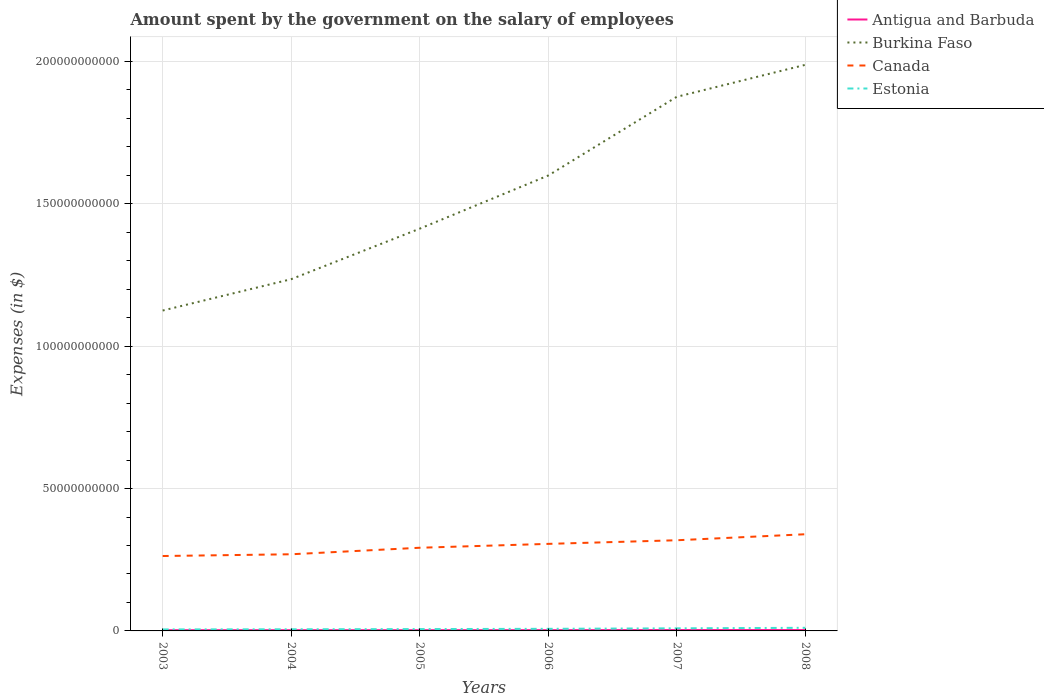Across all years, what is the maximum amount spent on the salary of employees by the government in Estonia?
Your response must be concise. 5.26e+08. What is the total amount spent on the salary of employees by the government in Antigua and Barbuda in the graph?
Give a very brief answer. -1.80e+07. What is the difference between the highest and the second highest amount spent on the salary of employees by the government in Canada?
Keep it short and to the point. 7.64e+09. What is the difference between the highest and the lowest amount spent on the salary of employees by the government in Burkina Faso?
Provide a short and direct response. 3. Is the amount spent on the salary of employees by the government in Estonia strictly greater than the amount spent on the salary of employees by the government in Antigua and Barbuda over the years?
Your response must be concise. No. What is the difference between two consecutive major ticks on the Y-axis?
Offer a very short reply. 5.00e+1. Does the graph contain any zero values?
Make the answer very short. No. Does the graph contain grids?
Ensure brevity in your answer.  Yes. How are the legend labels stacked?
Offer a terse response. Vertical. What is the title of the graph?
Ensure brevity in your answer.  Amount spent by the government on the salary of employees. What is the label or title of the Y-axis?
Give a very brief answer. Expenses (in $). What is the Expenses (in $) of Antigua and Barbuda in 2003?
Your answer should be compact. 2.50e+08. What is the Expenses (in $) in Burkina Faso in 2003?
Give a very brief answer. 1.13e+11. What is the Expenses (in $) in Canada in 2003?
Provide a short and direct response. 2.63e+1. What is the Expenses (in $) in Estonia in 2003?
Your response must be concise. 5.26e+08. What is the Expenses (in $) in Antigua and Barbuda in 2004?
Your answer should be very brief. 2.51e+08. What is the Expenses (in $) of Burkina Faso in 2004?
Keep it short and to the point. 1.24e+11. What is the Expenses (in $) of Canada in 2004?
Your response must be concise. 2.69e+1. What is the Expenses (in $) of Estonia in 2004?
Provide a short and direct response. 5.75e+08. What is the Expenses (in $) of Antigua and Barbuda in 2005?
Make the answer very short. 2.53e+08. What is the Expenses (in $) in Burkina Faso in 2005?
Your answer should be very brief. 1.41e+11. What is the Expenses (in $) of Canada in 2005?
Offer a very short reply. 2.92e+1. What is the Expenses (in $) of Estonia in 2005?
Give a very brief answer. 6.46e+08. What is the Expenses (in $) of Antigua and Barbuda in 2006?
Provide a short and direct response. 2.68e+08. What is the Expenses (in $) of Burkina Faso in 2006?
Provide a succinct answer. 1.60e+11. What is the Expenses (in $) of Canada in 2006?
Make the answer very short. 3.06e+1. What is the Expenses (in $) of Estonia in 2006?
Provide a short and direct response. 7.36e+08. What is the Expenses (in $) of Antigua and Barbuda in 2007?
Provide a short and direct response. 3.09e+08. What is the Expenses (in $) of Burkina Faso in 2007?
Provide a succinct answer. 1.88e+11. What is the Expenses (in $) of Canada in 2007?
Ensure brevity in your answer.  3.18e+1. What is the Expenses (in $) in Estonia in 2007?
Provide a succinct answer. 9.16e+08. What is the Expenses (in $) of Antigua and Barbuda in 2008?
Your response must be concise. 3.00e+08. What is the Expenses (in $) of Burkina Faso in 2008?
Make the answer very short. 1.99e+11. What is the Expenses (in $) in Canada in 2008?
Provide a short and direct response. 3.40e+1. What is the Expenses (in $) of Estonia in 2008?
Your response must be concise. 1.09e+09. Across all years, what is the maximum Expenses (in $) in Antigua and Barbuda?
Your response must be concise. 3.09e+08. Across all years, what is the maximum Expenses (in $) of Burkina Faso?
Offer a terse response. 1.99e+11. Across all years, what is the maximum Expenses (in $) in Canada?
Offer a very short reply. 3.40e+1. Across all years, what is the maximum Expenses (in $) in Estonia?
Your answer should be compact. 1.09e+09. Across all years, what is the minimum Expenses (in $) in Antigua and Barbuda?
Provide a short and direct response. 2.50e+08. Across all years, what is the minimum Expenses (in $) in Burkina Faso?
Provide a short and direct response. 1.13e+11. Across all years, what is the minimum Expenses (in $) of Canada?
Your answer should be compact. 2.63e+1. Across all years, what is the minimum Expenses (in $) in Estonia?
Offer a very short reply. 5.26e+08. What is the total Expenses (in $) of Antigua and Barbuda in the graph?
Ensure brevity in your answer.  1.63e+09. What is the total Expenses (in $) of Burkina Faso in the graph?
Provide a short and direct response. 9.24e+11. What is the total Expenses (in $) in Canada in the graph?
Your response must be concise. 1.79e+11. What is the total Expenses (in $) in Estonia in the graph?
Provide a succinct answer. 4.49e+09. What is the difference between the Expenses (in $) in Antigua and Barbuda in 2003 and that in 2004?
Offer a very short reply. -9.00e+05. What is the difference between the Expenses (in $) in Burkina Faso in 2003 and that in 2004?
Ensure brevity in your answer.  -1.10e+1. What is the difference between the Expenses (in $) in Canada in 2003 and that in 2004?
Your response must be concise. -6.14e+08. What is the difference between the Expenses (in $) in Estonia in 2003 and that in 2004?
Give a very brief answer. -4.92e+07. What is the difference between the Expenses (in $) of Antigua and Barbuda in 2003 and that in 2005?
Your response must be concise. -2.60e+06. What is the difference between the Expenses (in $) of Burkina Faso in 2003 and that in 2005?
Provide a short and direct response. -2.88e+1. What is the difference between the Expenses (in $) of Canada in 2003 and that in 2005?
Your answer should be compact. -2.90e+09. What is the difference between the Expenses (in $) in Estonia in 2003 and that in 2005?
Provide a short and direct response. -1.20e+08. What is the difference between the Expenses (in $) in Antigua and Barbuda in 2003 and that in 2006?
Your answer should be compact. -1.80e+07. What is the difference between the Expenses (in $) in Burkina Faso in 2003 and that in 2006?
Keep it short and to the point. -4.74e+1. What is the difference between the Expenses (in $) in Canada in 2003 and that in 2006?
Ensure brevity in your answer.  -4.26e+09. What is the difference between the Expenses (in $) of Estonia in 2003 and that in 2006?
Keep it short and to the point. -2.10e+08. What is the difference between the Expenses (in $) of Antigua and Barbuda in 2003 and that in 2007?
Your answer should be compact. -5.88e+07. What is the difference between the Expenses (in $) of Burkina Faso in 2003 and that in 2007?
Your answer should be very brief. -7.51e+1. What is the difference between the Expenses (in $) in Canada in 2003 and that in 2007?
Your response must be concise. -5.54e+09. What is the difference between the Expenses (in $) of Estonia in 2003 and that in 2007?
Give a very brief answer. -3.90e+08. What is the difference between the Expenses (in $) of Antigua and Barbuda in 2003 and that in 2008?
Offer a very short reply. -5.02e+07. What is the difference between the Expenses (in $) in Burkina Faso in 2003 and that in 2008?
Give a very brief answer. -8.63e+1. What is the difference between the Expenses (in $) in Canada in 2003 and that in 2008?
Your answer should be compact. -7.64e+09. What is the difference between the Expenses (in $) in Estonia in 2003 and that in 2008?
Provide a succinct answer. -5.68e+08. What is the difference between the Expenses (in $) in Antigua and Barbuda in 2004 and that in 2005?
Keep it short and to the point. -1.70e+06. What is the difference between the Expenses (in $) in Burkina Faso in 2004 and that in 2005?
Keep it short and to the point. -1.77e+1. What is the difference between the Expenses (in $) of Canada in 2004 and that in 2005?
Provide a short and direct response. -2.29e+09. What is the difference between the Expenses (in $) in Estonia in 2004 and that in 2005?
Your answer should be very brief. -7.10e+07. What is the difference between the Expenses (in $) in Antigua and Barbuda in 2004 and that in 2006?
Offer a very short reply. -1.71e+07. What is the difference between the Expenses (in $) in Burkina Faso in 2004 and that in 2006?
Give a very brief answer. -3.64e+1. What is the difference between the Expenses (in $) in Canada in 2004 and that in 2006?
Offer a terse response. -3.65e+09. What is the difference between the Expenses (in $) in Estonia in 2004 and that in 2006?
Provide a succinct answer. -1.60e+08. What is the difference between the Expenses (in $) of Antigua and Barbuda in 2004 and that in 2007?
Make the answer very short. -5.79e+07. What is the difference between the Expenses (in $) in Burkina Faso in 2004 and that in 2007?
Your answer should be compact. -6.41e+1. What is the difference between the Expenses (in $) in Canada in 2004 and that in 2007?
Offer a terse response. -4.92e+09. What is the difference between the Expenses (in $) of Estonia in 2004 and that in 2007?
Provide a short and direct response. -3.41e+08. What is the difference between the Expenses (in $) in Antigua and Barbuda in 2004 and that in 2008?
Make the answer very short. -4.93e+07. What is the difference between the Expenses (in $) of Burkina Faso in 2004 and that in 2008?
Your answer should be compact. -7.53e+1. What is the difference between the Expenses (in $) in Canada in 2004 and that in 2008?
Your answer should be very brief. -7.03e+09. What is the difference between the Expenses (in $) of Estonia in 2004 and that in 2008?
Give a very brief answer. -5.19e+08. What is the difference between the Expenses (in $) in Antigua and Barbuda in 2005 and that in 2006?
Your answer should be very brief. -1.54e+07. What is the difference between the Expenses (in $) of Burkina Faso in 2005 and that in 2006?
Offer a terse response. -1.87e+1. What is the difference between the Expenses (in $) of Canada in 2005 and that in 2006?
Your answer should be very brief. -1.36e+09. What is the difference between the Expenses (in $) of Estonia in 2005 and that in 2006?
Ensure brevity in your answer.  -8.94e+07. What is the difference between the Expenses (in $) of Antigua and Barbuda in 2005 and that in 2007?
Offer a terse response. -5.62e+07. What is the difference between the Expenses (in $) of Burkina Faso in 2005 and that in 2007?
Your response must be concise. -4.63e+1. What is the difference between the Expenses (in $) in Canada in 2005 and that in 2007?
Ensure brevity in your answer.  -2.63e+09. What is the difference between the Expenses (in $) of Estonia in 2005 and that in 2007?
Make the answer very short. -2.70e+08. What is the difference between the Expenses (in $) in Antigua and Barbuda in 2005 and that in 2008?
Your answer should be very brief. -4.76e+07. What is the difference between the Expenses (in $) in Burkina Faso in 2005 and that in 2008?
Your response must be concise. -5.75e+1. What is the difference between the Expenses (in $) in Canada in 2005 and that in 2008?
Provide a succinct answer. -4.74e+09. What is the difference between the Expenses (in $) of Estonia in 2005 and that in 2008?
Your answer should be very brief. -4.48e+08. What is the difference between the Expenses (in $) in Antigua and Barbuda in 2006 and that in 2007?
Offer a terse response. -4.08e+07. What is the difference between the Expenses (in $) of Burkina Faso in 2006 and that in 2007?
Your response must be concise. -2.76e+1. What is the difference between the Expenses (in $) in Canada in 2006 and that in 2007?
Offer a very short reply. -1.27e+09. What is the difference between the Expenses (in $) of Estonia in 2006 and that in 2007?
Make the answer very short. -1.81e+08. What is the difference between the Expenses (in $) in Antigua and Barbuda in 2006 and that in 2008?
Make the answer very short. -3.22e+07. What is the difference between the Expenses (in $) in Burkina Faso in 2006 and that in 2008?
Ensure brevity in your answer.  -3.89e+1. What is the difference between the Expenses (in $) in Canada in 2006 and that in 2008?
Keep it short and to the point. -3.38e+09. What is the difference between the Expenses (in $) of Estonia in 2006 and that in 2008?
Ensure brevity in your answer.  -3.58e+08. What is the difference between the Expenses (in $) of Antigua and Barbuda in 2007 and that in 2008?
Provide a succinct answer. 8.60e+06. What is the difference between the Expenses (in $) of Burkina Faso in 2007 and that in 2008?
Your response must be concise. -1.12e+1. What is the difference between the Expenses (in $) of Canada in 2007 and that in 2008?
Provide a short and direct response. -2.11e+09. What is the difference between the Expenses (in $) in Estonia in 2007 and that in 2008?
Provide a succinct answer. -1.78e+08. What is the difference between the Expenses (in $) of Antigua and Barbuda in 2003 and the Expenses (in $) of Burkina Faso in 2004?
Ensure brevity in your answer.  -1.23e+11. What is the difference between the Expenses (in $) in Antigua and Barbuda in 2003 and the Expenses (in $) in Canada in 2004?
Provide a short and direct response. -2.67e+1. What is the difference between the Expenses (in $) of Antigua and Barbuda in 2003 and the Expenses (in $) of Estonia in 2004?
Provide a short and direct response. -3.25e+08. What is the difference between the Expenses (in $) of Burkina Faso in 2003 and the Expenses (in $) of Canada in 2004?
Keep it short and to the point. 8.56e+1. What is the difference between the Expenses (in $) of Burkina Faso in 2003 and the Expenses (in $) of Estonia in 2004?
Ensure brevity in your answer.  1.12e+11. What is the difference between the Expenses (in $) of Canada in 2003 and the Expenses (in $) of Estonia in 2004?
Give a very brief answer. 2.57e+1. What is the difference between the Expenses (in $) of Antigua and Barbuda in 2003 and the Expenses (in $) of Burkina Faso in 2005?
Your answer should be compact. -1.41e+11. What is the difference between the Expenses (in $) of Antigua and Barbuda in 2003 and the Expenses (in $) of Canada in 2005?
Give a very brief answer. -2.90e+1. What is the difference between the Expenses (in $) in Antigua and Barbuda in 2003 and the Expenses (in $) in Estonia in 2005?
Provide a short and direct response. -3.96e+08. What is the difference between the Expenses (in $) in Burkina Faso in 2003 and the Expenses (in $) in Canada in 2005?
Make the answer very short. 8.33e+1. What is the difference between the Expenses (in $) in Burkina Faso in 2003 and the Expenses (in $) in Estonia in 2005?
Your answer should be very brief. 1.12e+11. What is the difference between the Expenses (in $) of Canada in 2003 and the Expenses (in $) of Estonia in 2005?
Give a very brief answer. 2.57e+1. What is the difference between the Expenses (in $) in Antigua and Barbuda in 2003 and the Expenses (in $) in Burkina Faso in 2006?
Offer a terse response. -1.60e+11. What is the difference between the Expenses (in $) of Antigua and Barbuda in 2003 and the Expenses (in $) of Canada in 2006?
Keep it short and to the point. -3.03e+1. What is the difference between the Expenses (in $) in Antigua and Barbuda in 2003 and the Expenses (in $) in Estonia in 2006?
Your response must be concise. -4.85e+08. What is the difference between the Expenses (in $) of Burkina Faso in 2003 and the Expenses (in $) of Canada in 2006?
Provide a short and direct response. 8.20e+1. What is the difference between the Expenses (in $) of Burkina Faso in 2003 and the Expenses (in $) of Estonia in 2006?
Your response must be concise. 1.12e+11. What is the difference between the Expenses (in $) of Canada in 2003 and the Expenses (in $) of Estonia in 2006?
Make the answer very short. 2.56e+1. What is the difference between the Expenses (in $) in Antigua and Barbuda in 2003 and the Expenses (in $) in Burkina Faso in 2007?
Ensure brevity in your answer.  -1.87e+11. What is the difference between the Expenses (in $) in Antigua and Barbuda in 2003 and the Expenses (in $) in Canada in 2007?
Offer a terse response. -3.16e+1. What is the difference between the Expenses (in $) of Antigua and Barbuda in 2003 and the Expenses (in $) of Estonia in 2007?
Your response must be concise. -6.66e+08. What is the difference between the Expenses (in $) in Burkina Faso in 2003 and the Expenses (in $) in Canada in 2007?
Give a very brief answer. 8.07e+1. What is the difference between the Expenses (in $) in Burkina Faso in 2003 and the Expenses (in $) in Estonia in 2007?
Ensure brevity in your answer.  1.12e+11. What is the difference between the Expenses (in $) in Canada in 2003 and the Expenses (in $) in Estonia in 2007?
Give a very brief answer. 2.54e+1. What is the difference between the Expenses (in $) of Antigua and Barbuda in 2003 and the Expenses (in $) of Burkina Faso in 2008?
Your answer should be very brief. -1.99e+11. What is the difference between the Expenses (in $) in Antigua and Barbuda in 2003 and the Expenses (in $) in Canada in 2008?
Give a very brief answer. -3.37e+1. What is the difference between the Expenses (in $) in Antigua and Barbuda in 2003 and the Expenses (in $) in Estonia in 2008?
Your response must be concise. -8.44e+08. What is the difference between the Expenses (in $) of Burkina Faso in 2003 and the Expenses (in $) of Canada in 2008?
Give a very brief answer. 7.86e+1. What is the difference between the Expenses (in $) in Burkina Faso in 2003 and the Expenses (in $) in Estonia in 2008?
Your response must be concise. 1.11e+11. What is the difference between the Expenses (in $) of Canada in 2003 and the Expenses (in $) of Estonia in 2008?
Give a very brief answer. 2.52e+1. What is the difference between the Expenses (in $) of Antigua and Barbuda in 2004 and the Expenses (in $) of Burkina Faso in 2005?
Keep it short and to the point. -1.41e+11. What is the difference between the Expenses (in $) in Antigua and Barbuda in 2004 and the Expenses (in $) in Canada in 2005?
Your answer should be compact. -2.90e+1. What is the difference between the Expenses (in $) of Antigua and Barbuda in 2004 and the Expenses (in $) of Estonia in 2005?
Give a very brief answer. -3.95e+08. What is the difference between the Expenses (in $) in Burkina Faso in 2004 and the Expenses (in $) in Canada in 2005?
Give a very brief answer. 9.43e+1. What is the difference between the Expenses (in $) in Burkina Faso in 2004 and the Expenses (in $) in Estonia in 2005?
Ensure brevity in your answer.  1.23e+11. What is the difference between the Expenses (in $) of Canada in 2004 and the Expenses (in $) of Estonia in 2005?
Provide a short and direct response. 2.63e+1. What is the difference between the Expenses (in $) of Antigua and Barbuda in 2004 and the Expenses (in $) of Burkina Faso in 2006?
Keep it short and to the point. -1.60e+11. What is the difference between the Expenses (in $) in Antigua and Barbuda in 2004 and the Expenses (in $) in Canada in 2006?
Keep it short and to the point. -3.03e+1. What is the difference between the Expenses (in $) in Antigua and Barbuda in 2004 and the Expenses (in $) in Estonia in 2006?
Keep it short and to the point. -4.84e+08. What is the difference between the Expenses (in $) of Burkina Faso in 2004 and the Expenses (in $) of Canada in 2006?
Give a very brief answer. 9.30e+1. What is the difference between the Expenses (in $) of Burkina Faso in 2004 and the Expenses (in $) of Estonia in 2006?
Your answer should be compact. 1.23e+11. What is the difference between the Expenses (in $) in Canada in 2004 and the Expenses (in $) in Estonia in 2006?
Give a very brief answer. 2.62e+1. What is the difference between the Expenses (in $) in Antigua and Barbuda in 2004 and the Expenses (in $) in Burkina Faso in 2007?
Your answer should be very brief. -1.87e+11. What is the difference between the Expenses (in $) of Antigua and Barbuda in 2004 and the Expenses (in $) of Canada in 2007?
Offer a very short reply. -3.16e+1. What is the difference between the Expenses (in $) in Antigua and Barbuda in 2004 and the Expenses (in $) in Estonia in 2007?
Offer a terse response. -6.65e+08. What is the difference between the Expenses (in $) of Burkina Faso in 2004 and the Expenses (in $) of Canada in 2007?
Provide a short and direct response. 9.17e+1. What is the difference between the Expenses (in $) in Burkina Faso in 2004 and the Expenses (in $) in Estonia in 2007?
Offer a terse response. 1.23e+11. What is the difference between the Expenses (in $) of Canada in 2004 and the Expenses (in $) of Estonia in 2007?
Your answer should be very brief. 2.60e+1. What is the difference between the Expenses (in $) in Antigua and Barbuda in 2004 and the Expenses (in $) in Burkina Faso in 2008?
Offer a terse response. -1.99e+11. What is the difference between the Expenses (in $) in Antigua and Barbuda in 2004 and the Expenses (in $) in Canada in 2008?
Your response must be concise. -3.37e+1. What is the difference between the Expenses (in $) of Antigua and Barbuda in 2004 and the Expenses (in $) of Estonia in 2008?
Your response must be concise. -8.43e+08. What is the difference between the Expenses (in $) of Burkina Faso in 2004 and the Expenses (in $) of Canada in 2008?
Ensure brevity in your answer.  8.96e+1. What is the difference between the Expenses (in $) of Burkina Faso in 2004 and the Expenses (in $) of Estonia in 2008?
Ensure brevity in your answer.  1.22e+11. What is the difference between the Expenses (in $) of Canada in 2004 and the Expenses (in $) of Estonia in 2008?
Provide a short and direct response. 2.58e+1. What is the difference between the Expenses (in $) of Antigua and Barbuda in 2005 and the Expenses (in $) of Burkina Faso in 2006?
Offer a terse response. -1.60e+11. What is the difference between the Expenses (in $) of Antigua and Barbuda in 2005 and the Expenses (in $) of Canada in 2006?
Keep it short and to the point. -3.03e+1. What is the difference between the Expenses (in $) in Antigua and Barbuda in 2005 and the Expenses (in $) in Estonia in 2006?
Offer a terse response. -4.83e+08. What is the difference between the Expenses (in $) in Burkina Faso in 2005 and the Expenses (in $) in Canada in 2006?
Provide a short and direct response. 1.11e+11. What is the difference between the Expenses (in $) in Burkina Faso in 2005 and the Expenses (in $) in Estonia in 2006?
Keep it short and to the point. 1.41e+11. What is the difference between the Expenses (in $) in Canada in 2005 and the Expenses (in $) in Estonia in 2006?
Offer a terse response. 2.85e+1. What is the difference between the Expenses (in $) in Antigua and Barbuda in 2005 and the Expenses (in $) in Burkina Faso in 2007?
Your answer should be compact. -1.87e+11. What is the difference between the Expenses (in $) of Antigua and Barbuda in 2005 and the Expenses (in $) of Canada in 2007?
Your answer should be compact. -3.16e+1. What is the difference between the Expenses (in $) of Antigua and Barbuda in 2005 and the Expenses (in $) of Estonia in 2007?
Offer a very short reply. -6.63e+08. What is the difference between the Expenses (in $) in Burkina Faso in 2005 and the Expenses (in $) in Canada in 2007?
Your answer should be compact. 1.09e+11. What is the difference between the Expenses (in $) of Burkina Faso in 2005 and the Expenses (in $) of Estonia in 2007?
Offer a very short reply. 1.40e+11. What is the difference between the Expenses (in $) in Canada in 2005 and the Expenses (in $) in Estonia in 2007?
Offer a terse response. 2.83e+1. What is the difference between the Expenses (in $) of Antigua and Barbuda in 2005 and the Expenses (in $) of Burkina Faso in 2008?
Provide a short and direct response. -1.99e+11. What is the difference between the Expenses (in $) in Antigua and Barbuda in 2005 and the Expenses (in $) in Canada in 2008?
Your answer should be compact. -3.37e+1. What is the difference between the Expenses (in $) of Antigua and Barbuda in 2005 and the Expenses (in $) of Estonia in 2008?
Give a very brief answer. -8.41e+08. What is the difference between the Expenses (in $) in Burkina Faso in 2005 and the Expenses (in $) in Canada in 2008?
Your response must be concise. 1.07e+11. What is the difference between the Expenses (in $) in Burkina Faso in 2005 and the Expenses (in $) in Estonia in 2008?
Provide a succinct answer. 1.40e+11. What is the difference between the Expenses (in $) in Canada in 2005 and the Expenses (in $) in Estonia in 2008?
Offer a very short reply. 2.81e+1. What is the difference between the Expenses (in $) of Antigua and Barbuda in 2006 and the Expenses (in $) of Burkina Faso in 2007?
Provide a succinct answer. -1.87e+11. What is the difference between the Expenses (in $) of Antigua and Barbuda in 2006 and the Expenses (in $) of Canada in 2007?
Provide a succinct answer. -3.16e+1. What is the difference between the Expenses (in $) of Antigua and Barbuda in 2006 and the Expenses (in $) of Estonia in 2007?
Provide a short and direct response. -6.48e+08. What is the difference between the Expenses (in $) of Burkina Faso in 2006 and the Expenses (in $) of Canada in 2007?
Make the answer very short. 1.28e+11. What is the difference between the Expenses (in $) of Burkina Faso in 2006 and the Expenses (in $) of Estonia in 2007?
Offer a very short reply. 1.59e+11. What is the difference between the Expenses (in $) of Canada in 2006 and the Expenses (in $) of Estonia in 2007?
Ensure brevity in your answer.  2.97e+1. What is the difference between the Expenses (in $) in Antigua and Barbuda in 2006 and the Expenses (in $) in Burkina Faso in 2008?
Offer a very short reply. -1.99e+11. What is the difference between the Expenses (in $) of Antigua and Barbuda in 2006 and the Expenses (in $) of Canada in 2008?
Make the answer very short. -3.37e+1. What is the difference between the Expenses (in $) in Antigua and Barbuda in 2006 and the Expenses (in $) in Estonia in 2008?
Keep it short and to the point. -8.26e+08. What is the difference between the Expenses (in $) in Burkina Faso in 2006 and the Expenses (in $) in Canada in 2008?
Keep it short and to the point. 1.26e+11. What is the difference between the Expenses (in $) in Burkina Faso in 2006 and the Expenses (in $) in Estonia in 2008?
Your answer should be very brief. 1.59e+11. What is the difference between the Expenses (in $) of Canada in 2006 and the Expenses (in $) of Estonia in 2008?
Your response must be concise. 2.95e+1. What is the difference between the Expenses (in $) in Antigua and Barbuda in 2007 and the Expenses (in $) in Burkina Faso in 2008?
Offer a terse response. -1.99e+11. What is the difference between the Expenses (in $) in Antigua and Barbuda in 2007 and the Expenses (in $) in Canada in 2008?
Offer a terse response. -3.36e+1. What is the difference between the Expenses (in $) of Antigua and Barbuda in 2007 and the Expenses (in $) of Estonia in 2008?
Offer a terse response. -7.85e+08. What is the difference between the Expenses (in $) of Burkina Faso in 2007 and the Expenses (in $) of Canada in 2008?
Make the answer very short. 1.54e+11. What is the difference between the Expenses (in $) of Burkina Faso in 2007 and the Expenses (in $) of Estonia in 2008?
Your response must be concise. 1.87e+11. What is the difference between the Expenses (in $) in Canada in 2007 and the Expenses (in $) in Estonia in 2008?
Give a very brief answer. 3.08e+1. What is the average Expenses (in $) in Antigua and Barbuda per year?
Your response must be concise. 2.72e+08. What is the average Expenses (in $) of Burkina Faso per year?
Make the answer very short. 1.54e+11. What is the average Expenses (in $) of Canada per year?
Ensure brevity in your answer.  2.98e+1. What is the average Expenses (in $) in Estonia per year?
Your answer should be compact. 7.49e+08. In the year 2003, what is the difference between the Expenses (in $) of Antigua and Barbuda and Expenses (in $) of Burkina Faso?
Your response must be concise. -1.12e+11. In the year 2003, what is the difference between the Expenses (in $) of Antigua and Barbuda and Expenses (in $) of Canada?
Offer a terse response. -2.61e+1. In the year 2003, what is the difference between the Expenses (in $) of Antigua and Barbuda and Expenses (in $) of Estonia?
Your response must be concise. -2.76e+08. In the year 2003, what is the difference between the Expenses (in $) of Burkina Faso and Expenses (in $) of Canada?
Give a very brief answer. 8.62e+1. In the year 2003, what is the difference between the Expenses (in $) in Burkina Faso and Expenses (in $) in Estonia?
Offer a very short reply. 1.12e+11. In the year 2003, what is the difference between the Expenses (in $) in Canada and Expenses (in $) in Estonia?
Your answer should be very brief. 2.58e+1. In the year 2004, what is the difference between the Expenses (in $) in Antigua and Barbuda and Expenses (in $) in Burkina Faso?
Ensure brevity in your answer.  -1.23e+11. In the year 2004, what is the difference between the Expenses (in $) in Antigua and Barbuda and Expenses (in $) in Canada?
Offer a very short reply. -2.67e+1. In the year 2004, what is the difference between the Expenses (in $) in Antigua and Barbuda and Expenses (in $) in Estonia?
Your answer should be compact. -3.24e+08. In the year 2004, what is the difference between the Expenses (in $) of Burkina Faso and Expenses (in $) of Canada?
Offer a very short reply. 9.66e+1. In the year 2004, what is the difference between the Expenses (in $) of Burkina Faso and Expenses (in $) of Estonia?
Your answer should be compact. 1.23e+11. In the year 2004, what is the difference between the Expenses (in $) of Canada and Expenses (in $) of Estonia?
Provide a succinct answer. 2.63e+1. In the year 2005, what is the difference between the Expenses (in $) in Antigua and Barbuda and Expenses (in $) in Burkina Faso?
Keep it short and to the point. -1.41e+11. In the year 2005, what is the difference between the Expenses (in $) of Antigua and Barbuda and Expenses (in $) of Canada?
Make the answer very short. -2.90e+1. In the year 2005, what is the difference between the Expenses (in $) of Antigua and Barbuda and Expenses (in $) of Estonia?
Give a very brief answer. -3.93e+08. In the year 2005, what is the difference between the Expenses (in $) of Burkina Faso and Expenses (in $) of Canada?
Keep it short and to the point. 1.12e+11. In the year 2005, what is the difference between the Expenses (in $) of Burkina Faso and Expenses (in $) of Estonia?
Your answer should be very brief. 1.41e+11. In the year 2005, what is the difference between the Expenses (in $) in Canada and Expenses (in $) in Estonia?
Make the answer very short. 2.86e+1. In the year 2006, what is the difference between the Expenses (in $) in Antigua and Barbuda and Expenses (in $) in Burkina Faso?
Ensure brevity in your answer.  -1.60e+11. In the year 2006, what is the difference between the Expenses (in $) of Antigua and Barbuda and Expenses (in $) of Canada?
Your answer should be very brief. -3.03e+1. In the year 2006, what is the difference between the Expenses (in $) in Antigua and Barbuda and Expenses (in $) in Estonia?
Your answer should be compact. -4.67e+08. In the year 2006, what is the difference between the Expenses (in $) in Burkina Faso and Expenses (in $) in Canada?
Your answer should be very brief. 1.29e+11. In the year 2006, what is the difference between the Expenses (in $) of Burkina Faso and Expenses (in $) of Estonia?
Your answer should be very brief. 1.59e+11. In the year 2006, what is the difference between the Expenses (in $) in Canada and Expenses (in $) in Estonia?
Offer a terse response. 2.98e+1. In the year 2007, what is the difference between the Expenses (in $) in Antigua and Barbuda and Expenses (in $) in Burkina Faso?
Your response must be concise. -1.87e+11. In the year 2007, what is the difference between the Expenses (in $) in Antigua and Barbuda and Expenses (in $) in Canada?
Your answer should be very brief. -3.15e+1. In the year 2007, what is the difference between the Expenses (in $) of Antigua and Barbuda and Expenses (in $) of Estonia?
Give a very brief answer. -6.07e+08. In the year 2007, what is the difference between the Expenses (in $) in Burkina Faso and Expenses (in $) in Canada?
Give a very brief answer. 1.56e+11. In the year 2007, what is the difference between the Expenses (in $) in Burkina Faso and Expenses (in $) in Estonia?
Keep it short and to the point. 1.87e+11. In the year 2007, what is the difference between the Expenses (in $) in Canada and Expenses (in $) in Estonia?
Give a very brief answer. 3.09e+1. In the year 2008, what is the difference between the Expenses (in $) in Antigua and Barbuda and Expenses (in $) in Burkina Faso?
Offer a terse response. -1.99e+11. In the year 2008, what is the difference between the Expenses (in $) of Antigua and Barbuda and Expenses (in $) of Canada?
Your answer should be very brief. -3.37e+1. In the year 2008, what is the difference between the Expenses (in $) in Antigua and Barbuda and Expenses (in $) in Estonia?
Provide a succinct answer. -7.94e+08. In the year 2008, what is the difference between the Expenses (in $) of Burkina Faso and Expenses (in $) of Canada?
Keep it short and to the point. 1.65e+11. In the year 2008, what is the difference between the Expenses (in $) in Burkina Faso and Expenses (in $) in Estonia?
Ensure brevity in your answer.  1.98e+11. In the year 2008, what is the difference between the Expenses (in $) of Canada and Expenses (in $) of Estonia?
Ensure brevity in your answer.  3.29e+1. What is the ratio of the Expenses (in $) in Antigua and Barbuda in 2003 to that in 2004?
Provide a short and direct response. 1. What is the ratio of the Expenses (in $) in Burkina Faso in 2003 to that in 2004?
Make the answer very short. 0.91. What is the ratio of the Expenses (in $) of Canada in 2003 to that in 2004?
Your answer should be compact. 0.98. What is the ratio of the Expenses (in $) of Estonia in 2003 to that in 2004?
Make the answer very short. 0.91. What is the ratio of the Expenses (in $) in Antigua and Barbuda in 2003 to that in 2005?
Keep it short and to the point. 0.99. What is the ratio of the Expenses (in $) in Burkina Faso in 2003 to that in 2005?
Offer a very short reply. 0.8. What is the ratio of the Expenses (in $) of Canada in 2003 to that in 2005?
Provide a succinct answer. 0.9. What is the ratio of the Expenses (in $) of Estonia in 2003 to that in 2005?
Provide a short and direct response. 0.81. What is the ratio of the Expenses (in $) in Antigua and Barbuda in 2003 to that in 2006?
Ensure brevity in your answer.  0.93. What is the ratio of the Expenses (in $) of Burkina Faso in 2003 to that in 2006?
Your response must be concise. 0.7. What is the ratio of the Expenses (in $) in Canada in 2003 to that in 2006?
Provide a short and direct response. 0.86. What is the ratio of the Expenses (in $) in Estonia in 2003 to that in 2006?
Ensure brevity in your answer.  0.71. What is the ratio of the Expenses (in $) in Antigua and Barbuda in 2003 to that in 2007?
Ensure brevity in your answer.  0.81. What is the ratio of the Expenses (in $) of Burkina Faso in 2003 to that in 2007?
Your answer should be very brief. 0.6. What is the ratio of the Expenses (in $) in Canada in 2003 to that in 2007?
Your answer should be compact. 0.83. What is the ratio of the Expenses (in $) in Estonia in 2003 to that in 2007?
Provide a short and direct response. 0.57. What is the ratio of the Expenses (in $) of Antigua and Barbuda in 2003 to that in 2008?
Give a very brief answer. 0.83. What is the ratio of the Expenses (in $) of Burkina Faso in 2003 to that in 2008?
Keep it short and to the point. 0.57. What is the ratio of the Expenses (in $) in Canada in 2003 to that in 2008?
Your response must be concise. 0.77. What is the ratio of the Expenses (in $) of Estonia in 2003 to that in 2008?
Keep it short and to the point. 0.48. What is the ratio of the Expenses (in $) of Burkina Faso in 2004 to that in 2005?
Your answer should be very brief. 0.87. What is the ratio of the Expenses (in $) in Canada in 2004 to that in 2005?
Give a very brief answer. 0.92. What is the ratio of the Expenses (in $) of Estonia in 2004 to that in 2005?
Your answer should be very brief. 0.89. What is the ratio of the Expenses (in $) in Antigua and Barbuda in 2004 to that in 2006?
Provide a succinct answer. 0.94. What is the ratio of the Expenses (in $) in Burkina Faso in 2004 to that in 2006?
Provide a short and direct response. 0.77. What is the ratio of the Expenses (in $) of Canada in 2004 to that in 2006?
Keep it short and to the point. 0.88. What is the ratio of the Expenses (in $) of Estonia in 2004 to that in 2006?
Provide a succinct answer. 0.78. What is the ratio of the Expenses (in $) of Antigua and Barbuda in 2004 to that in 2007?
Offer a terse response. 0.81. What is the ratio of the Expenses (in $) in Burkina Faso in 2004 to that in 2007?
Your answer should be very brief. 0.66. What is the ratio of the Expenses (in $) in Canada in 2004 to that in 2007?
Provide a succinct answer. 0.85. What is the ratio of the Expenses (in $) of Estonia in 2004 to that in 2007?
Your response must be concise. 0.63. What is the ratio of the Expenses (in $) in Antigua and Barbuda in 2004 to that in 2008?
Ensure brevity in your answer.  0.84. What is the ratio of the Expenses (in $) in Burkina Faso in 2004 to that in 2008?
Your answer should be very brief. 0.62. What is the ratio of the Expenses (in $) of Canada in 2004 to that in 2008?
Offer a very short reply. 0.79. What is the ratio of the Expenses (in $) in Estonia in 2004 to that in 2008?
Ensure brevity in your answer.  0.53. What is the ratio of the Expenses (in $) of Antigua and Barbuda in 2005 to that in 2006?
Give a very brief answer. 0.94. What is the ratio of the Expenses (in $) in Burkina Faso in 2005 to that in 2006?
Offer a very short reply. 0.88. What is the ratio of the Expenses (in $) in Canada in 2005 to that in 2006?
Make the answer very short. 0.96. What is the ratio of the Expenses (in $) in Estonia in 2005 to that in 2006?
Make the answer very short. 0.88. What is the ratio of the Expenses (in $) of Antigua and Barbuda in 2005 to that in 2007?
Your answer should be very brief. 0.82. What is the ratio of the Expenses (in $) of Burkina Faso in 2005 to that in 2007?
Provide a succinct answer. 0.75. What is the ratio of the Expenses (in $) in Canada in 2005 to that in 2007?
Your response must be concise. 0.92. What is the ratio of the Expenses (in $) of Estonia in 2005 to that in 2007?
Provide a succinct answer. 0.71. What is the ratio of the Expenses (in $) of Antigua and Barbuda in 2005 to that in 2008?
Your answer should be very brief. 0.84. What is the ratio of the Expenses (in $) of Burkina Faso in 2005 to that in 2008?
Offer a very short reply. 0.71. What is the ratio of the Expenses (in $) of Canada in 2005 to that in 2008?
Your response must be concise. 0.86. What is the ratio of the Expenses (in $) in Estonia in 2005 to that in 2008?
Ensure brevity in your answer.  0.59. What is the ratio of the Expenses (in $) in Antigua and Barbuda in 2006 to that in 2007?
Your answer should be very brief. 0.87. What is the ratio of the Expenses (in $) of Burkina Faso in 2006 to that in 2007?
Offer a terse response. 0.85. What is the ratio of the Expenses (in $) in Canada in 2006 to that in 2007?
Offer a very short reply. 0.96. What is the ratio of the Expenses (in $) of Estonia in 2006 to that in 2007?
Make the answer very short. 0.8. What is the ratio of the Expenses (in $) of Antigua and Barbuda in 2006 to that in 2008?
Offer a terse response. 0.89. What is the ratio of the Expenses (in $) of Burkina Faso in 2006 to that in 2008?
Make the answer very short. 0.8. What is the ratio of the Expenses (in $) in Canada in 2006 to that in 2008?
Ensure brevity in your answer.  0.9. What is the ratio of the Expenses (in $) of Estonia in 2006 to that in 2008?
Give a very brief answer. 0.67. What is the ratio of the Expenses (in $) of Antigua and Barbuda in 2007 to that in 2008?
Ensure brevity in your answer.  1.03. What is the ratio of the Expenses (in $) of Burkina Faso in 2007 to that in 2008?
Offer a very short reply. 0.94. What is the ratio of the Expenses (in $) in Canada in 2007 to that in 2008?
Provide a succinct answer. 0.94. What is the ratio of the Expenses (in $) of Estonia in 2007 to that in 2008?
Give a very brief answer. 0.84. What is the difference between the highest and the second highest Expenses (in $) in Antigua and Barbuda?
Offer a very short reply. 8.60e+06. What is the difference between the highest and the second highest Expenses (in $) of Burkina Faso?
Give a very brief answer. 1.12e+1. What is the difference between the highest and the second highest Expenses (in $) in Canada?
Your answer should be very brief. 2.11e+09. What is the difference between the highest and the second highest Expenses (in $) in Estonia?
Your response must be concise. 1.78e+08. What is the difference between the highest and the lowest Expenses (in $) of Antigua and Barbuda?
Make the answer very short. 5.88e+07. What is the difference between the highest and the lowest Expenses (in $) in Burkina Faso?
Your answer should be compact. 8.63e+1. What is the difference between the highest and the lowest Expenses (in $) of Canada?
Make the answer very short. 7.64e+09. What is the difference between the highest and the lowest Expenses (in $) in Estonia?
Offer a terse response. 5.68e+08. 